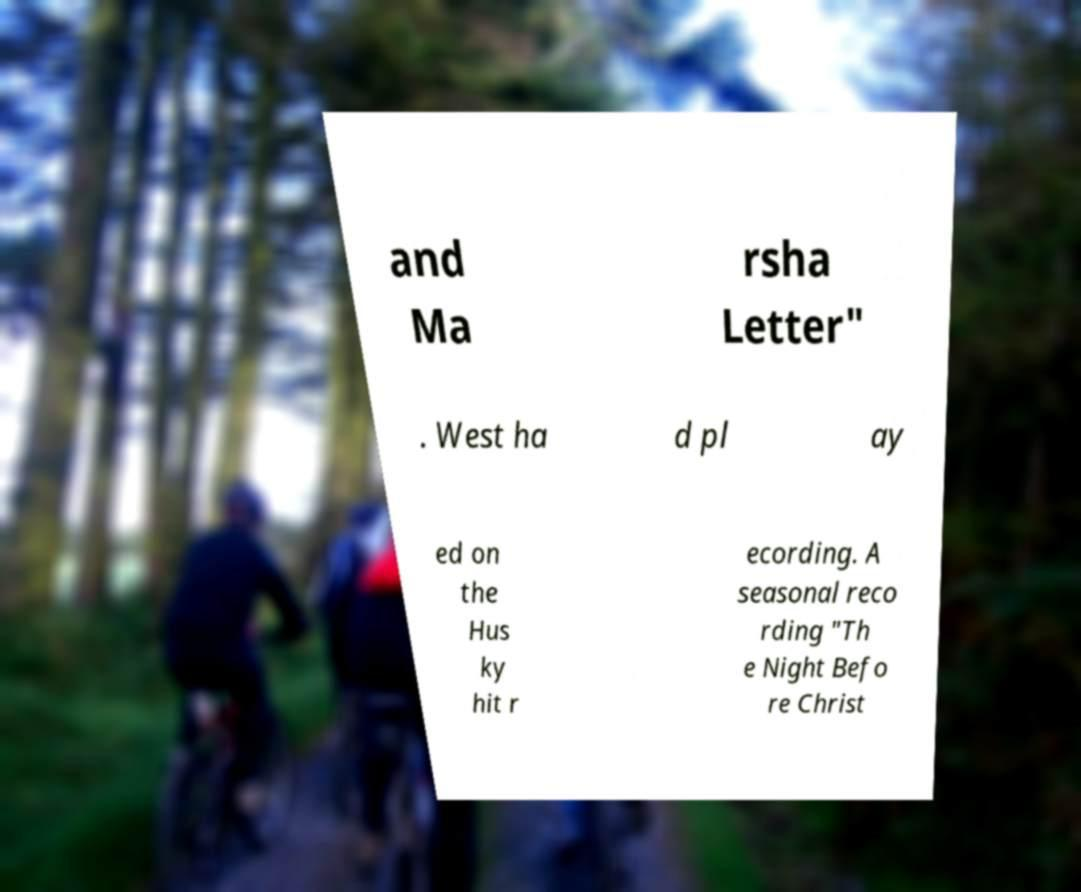For documentation purposes, I need the text within this image transcribed. Could you provide that? and Ma rsha Letter" . West ha d pl ay ed on the Hus ky hit r ecording. A seasonal reco rding "Th e Night Befo re Christ 